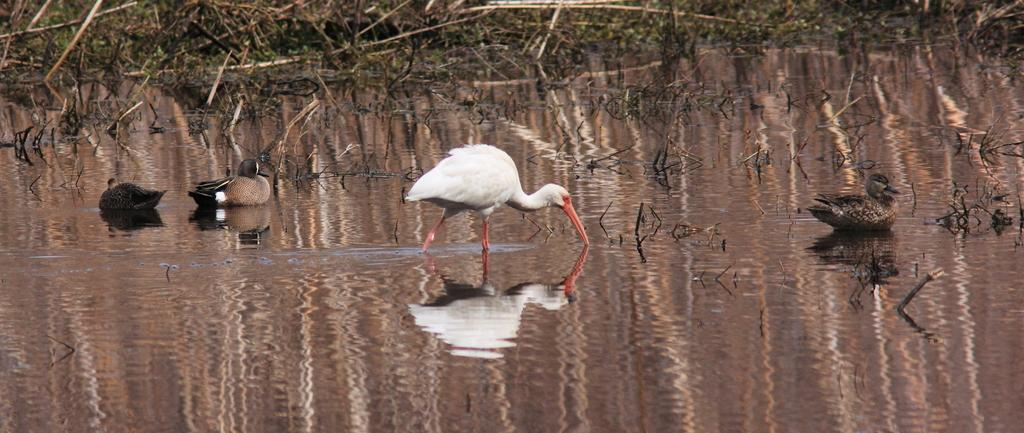What type of vegetation is visible in the image? There is grass in the image. What else can be seen in the image besides grass? There is water and birds visible in the image. What type of glue is being used by the birds in the image? There is no glue present in the image, and the birds are not using any glue. How many dolls can be seen interacting with the birds in the image? There are no dolls present in the image, so it is not possible to determine how many dolls might be interacting with the birds. 